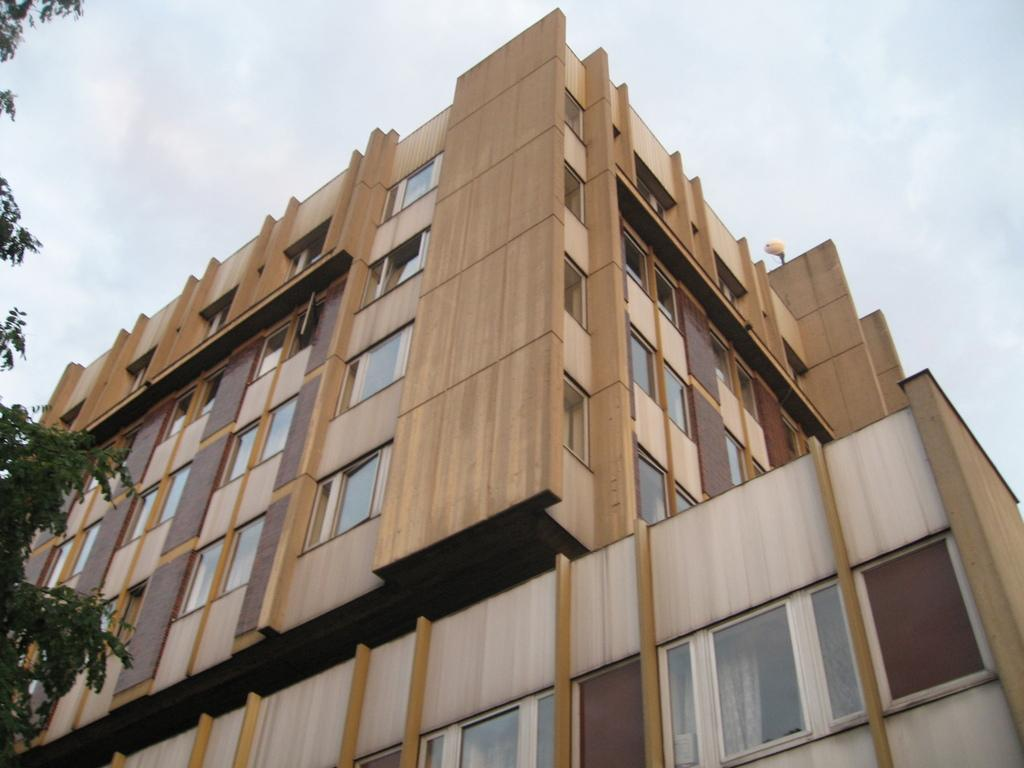What type of natural element is present in the image? There is a tree in the image. What type of structure is present in the image? There is a building in the image. What feature can be seen on the building? The building has windows. What can be seen in the background of the image? The sky is visible in the background of the image. What is the weather like in the image? The sky is cloudy, which suggests a partly cloudy or overcast day. Where is the drawer located in the image? There is no drawer present in the image. How many cherries are on top of the building in the image? There are no cherries present in the image. 